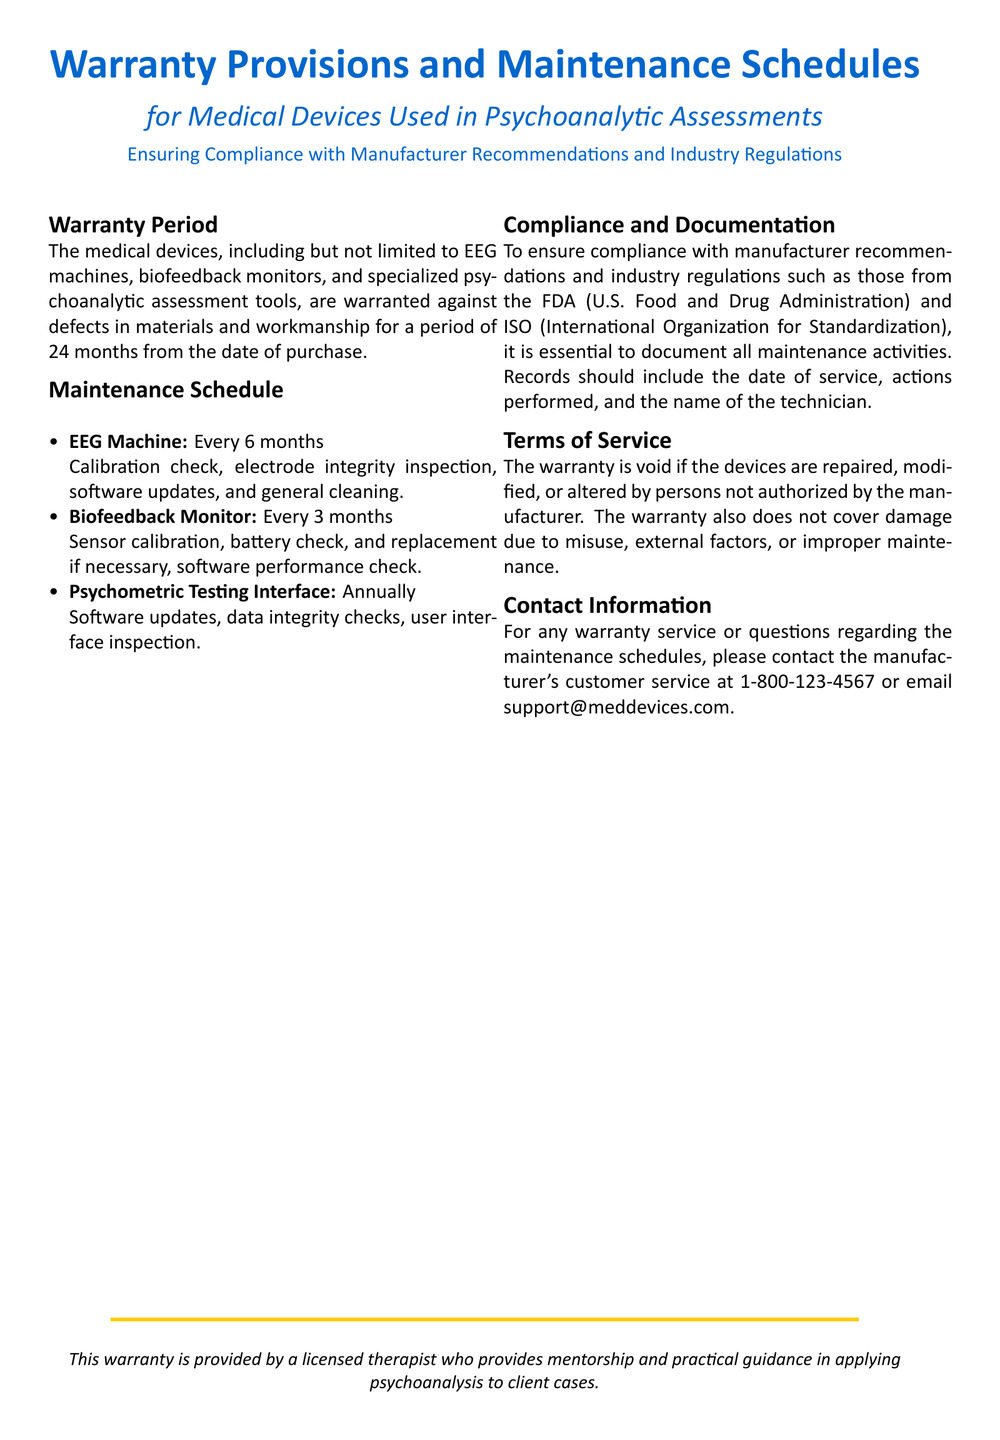What is the warranty period for medical devices? The warranty period is stated as 24 months from the date of purchase.
Answer: 24 months How often should the EEG machine be maintained? The document specifies that the EEG machine requires maintenance every 6 months.
Answer: Every 6 months What type of medical devices are covered under the warranty? The warranty covers EEG machines, biofeedback monitors, and specialized psychoanalytic assessment tools.
Answer: EEG machines, biofeedback monitors, psychoanalytic assessment tools What must be documented during maintenance activities? The documentation must include the date of service, actions performed, and the name of the technician.
Answer: Date of service, actions performed, name of the technician What happens to the warranty if the device is altered by unauthorized persons? It states that the warranty is void if devices are repaired, modified, or altered by unauthorized persons.
Answer: Voided How often should the biofeedback monitor be maintained? The maintenance schedule indicates that the biofeedback monitor should be checked every 3 months.
Answer: Every 3 months Who should be contacted for warranty service or questions? The document provides a contact number and email for warranty services through the manufacturer.
Answer: 1-800-123-4567 or support@meddevices.com Which organization is mentioned regarding industry regulations? The document mentions the FDA (U.S. Food and Drug Administration) as part of the regulations.
Answer: FDA What is not covered by the warranty? The warranty does not cover damage due to misuse, external factors, or improper maintenance.
Answer: Misuse, external factors, improper maintenance 